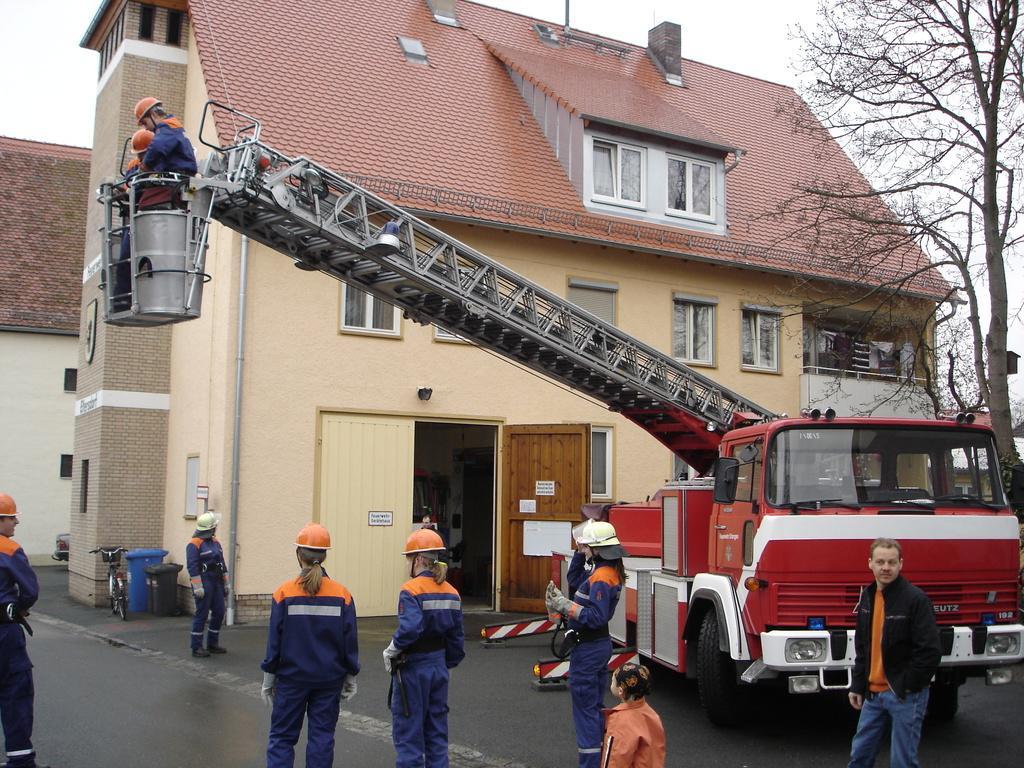Describe this image in one or two sentences. In the foreground of the picture I can see a few people standing on the road and I can see a few women wearing the hard hat on their head. I can see a fire engine on the road on the right side and there is a lifting device. In the background, I can see the house. There are trees on the top right side. I can see the bicycle and dustbins on the road on the left side. 